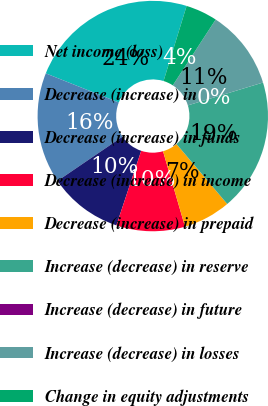Convert chart to OTSL. <chart><loc_0><loc_0><loc_500><loc_500><pie_chart><fcel>Net income (loss)<fcel>Decrease (increase) in<fcel>Decrease (increase) in funds<fcel>Decrease (increase) in income<fcel>Decrease (increase) in prepaid<fcel>Increase (decrease) in reserve<fcel>Increase (decrease) in future<fcel>Increase (decrease) in losses<fcel>Change in equity adjustments<nl><fcel>23.7%<fcel>15.55%<fcel>10.37%<fcel>9.63%<fcel>6.67%<fcel>18.52%<fcel>0.0%<fcel>11.11%<fcel>4.45%<nl></chart> 